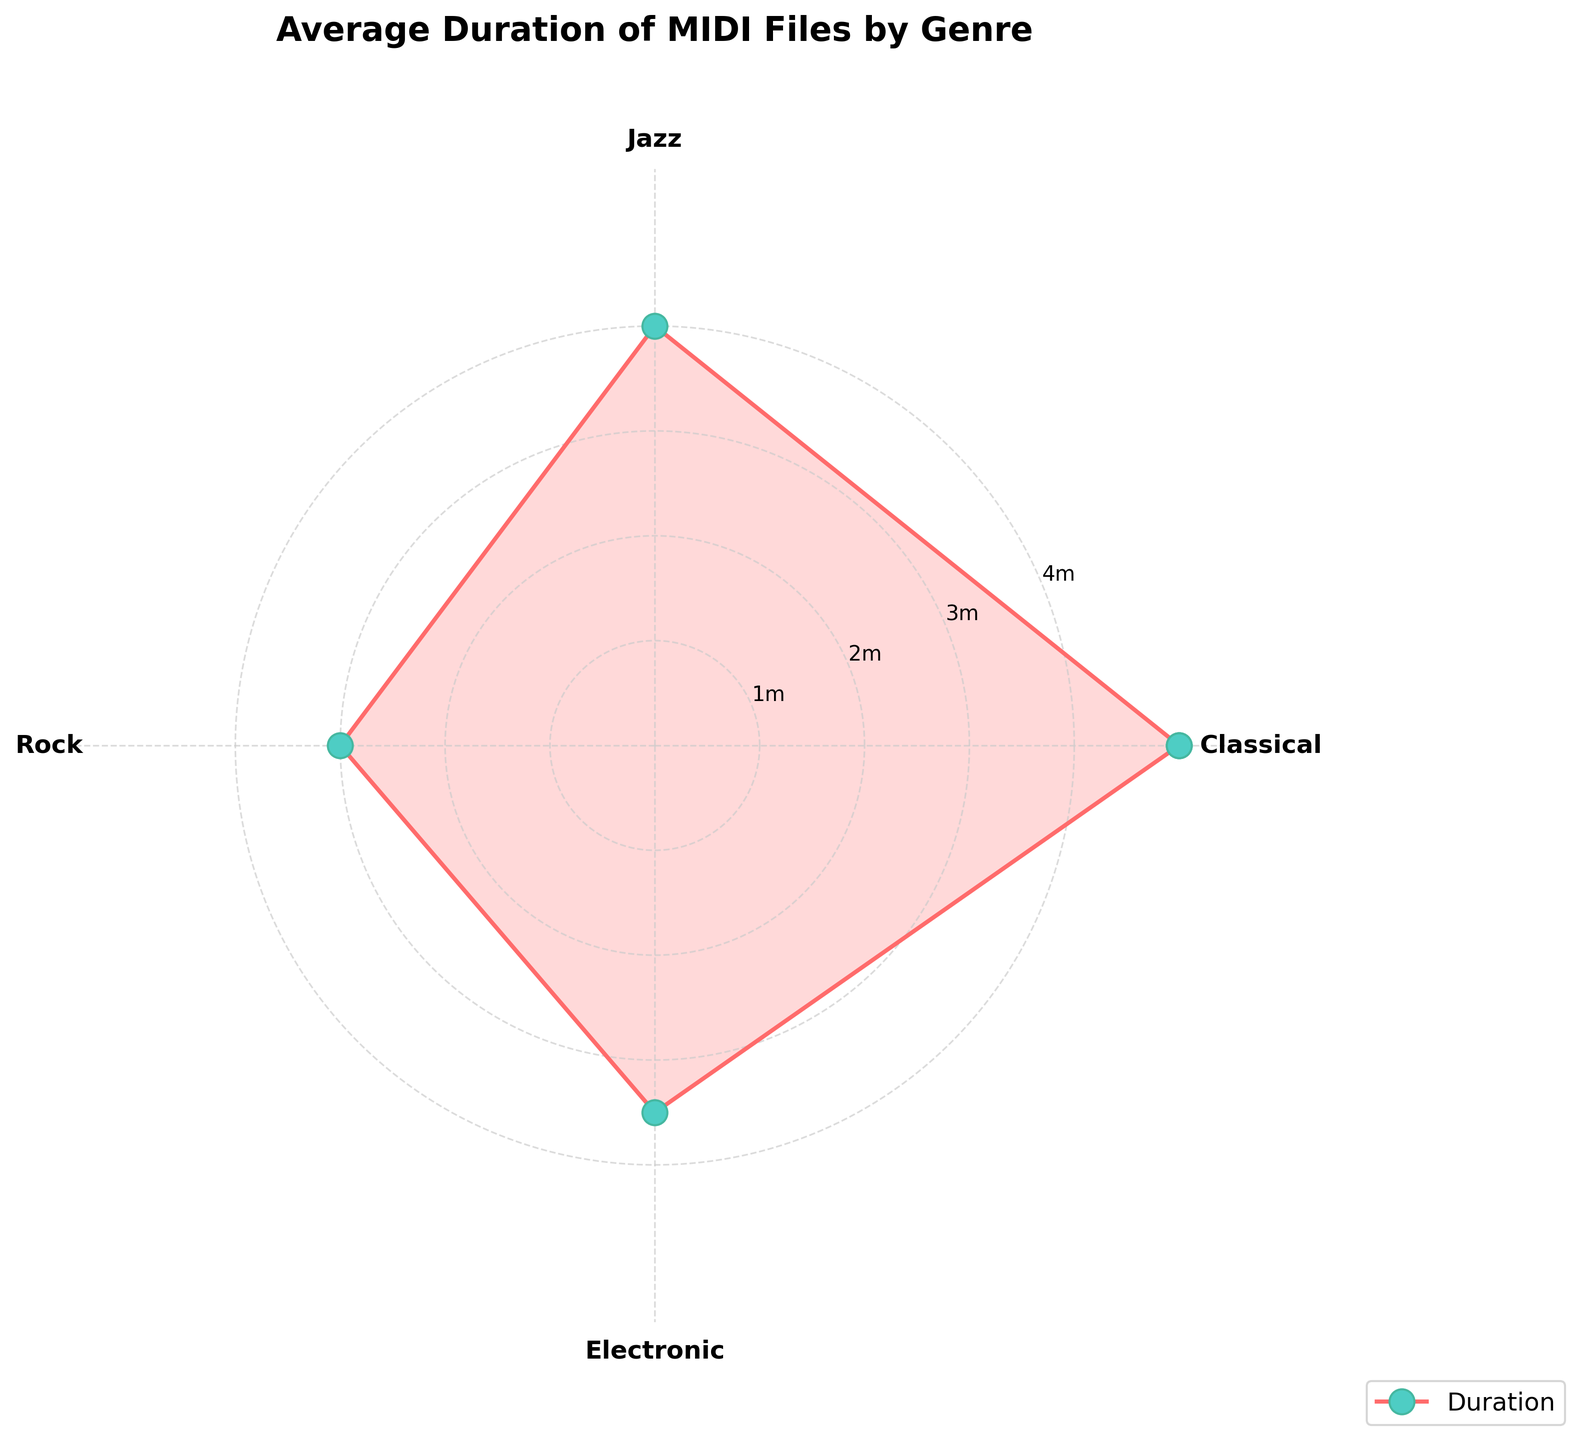What is the title of the chart? The title is written at the top of the figure. It reads "Average Duration of MIDI Files by Genre".
Answer: Average Duration of MIDI Files by Genre Which genre has the highest average duration? Each genre is represented around the circle, and lines extend outward based on their duration values. The genre with the line extending the furthest is "Classical".
Answer: Classical What is the average duration of Rock MIDI files in minutes? The duration values are in seconds. For Rock, it shows 180 seconds. Converting seconds to minutes: 180 seconds ÷ 60 = 3 minutes.
Answer: 3 minutes How many genres are represented in the chart? Count the number of unique labels around the polar plot. There are four genres listed: Classical, Jazz, Rock, Electronic.
Answer: 4 Which genre has a shorter average MIDI file duration than Jazz but longer than Rock? Comparing the positions around the circle: Electronic is shorter than Jazz (240 seconds) but longer than Rock (180 seconds) with a duration of 210 seconds.
Answer: Electronic By how many seconds is the average duration of Classical MIDI files longer than Electronic MIDI files? Classical has 300 seconds and Electronic has 210 seconds. Subtracting 210 from 300 gives: 300 - 210 = 90 seconds.
Answer: 90 seconds Which genre's average duration appears closest to 4 minutes? Looking at each duration and converting if necessary: 4 minutes is 240 seconds. Jazz is listed with an average duration of 240 seconds.
Answer: Jazz If the average duration of MIDI files needed to be at least 4 minutes for a specific experiment, which genres would qualify? 4 minutes is equivalent to 240 seconds. Both Classical (300 seconds) and Jazz (240 seconds) have durations of at least 4 minutes.
Answer: Classical, Jazz What is the total average duration of MIDI files for all genres combined in minutes? Sum all the durations: Classical (300) + Jazz (240) + Rock (180) + Electronic (210) = 930 seconds. Convert to minutes: 930 ÷ 60 = 15.5 minutes.
Answer: 15.5 minutes Which genre is represented with the smallest angle in the polar plot? There are four genres evenly distributed around the circle. Each genre occupies 1/4th of the circle, each with 90 degrees. No specific small angle.
Answer: Equal angles 